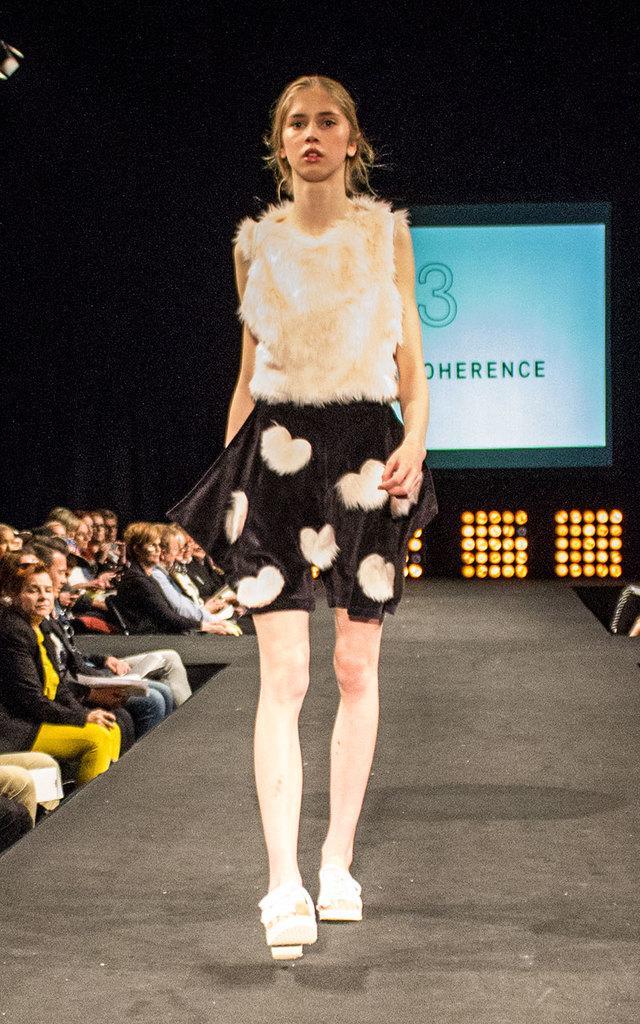Could you give a brief overview of what you see in this image? In this image, we can see a woman is walking on the floor. On the left side, we can see a group of people are sitting. Few are holding some objects. Background there is a screen, few lights. 